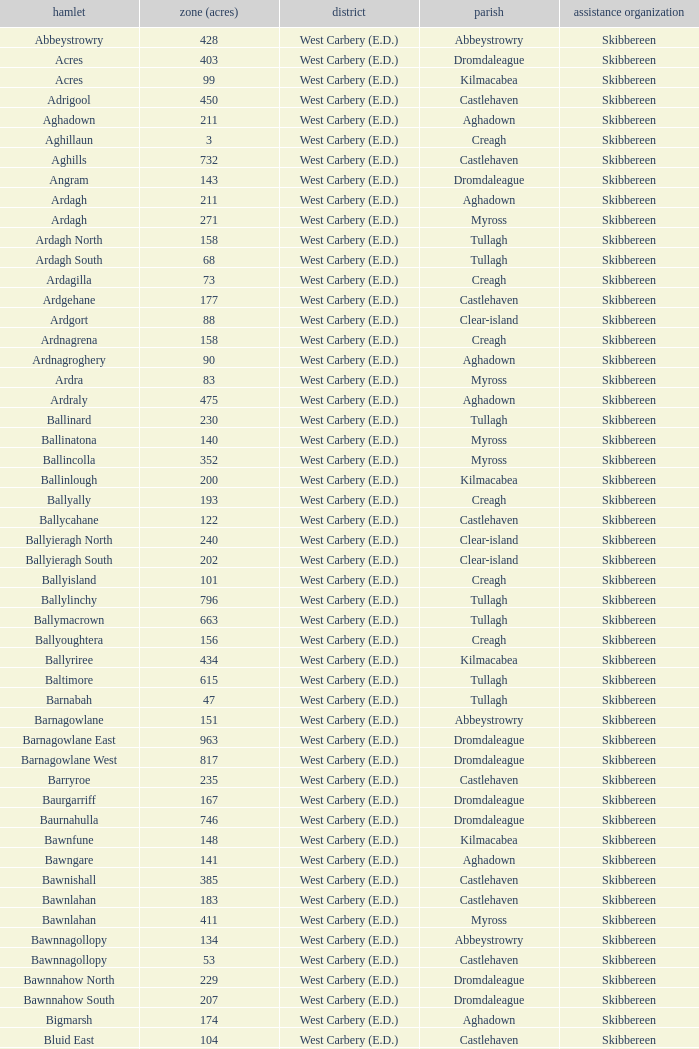What are the Baronies when the area (in acres) is 276? West Carbery (E.D.). 